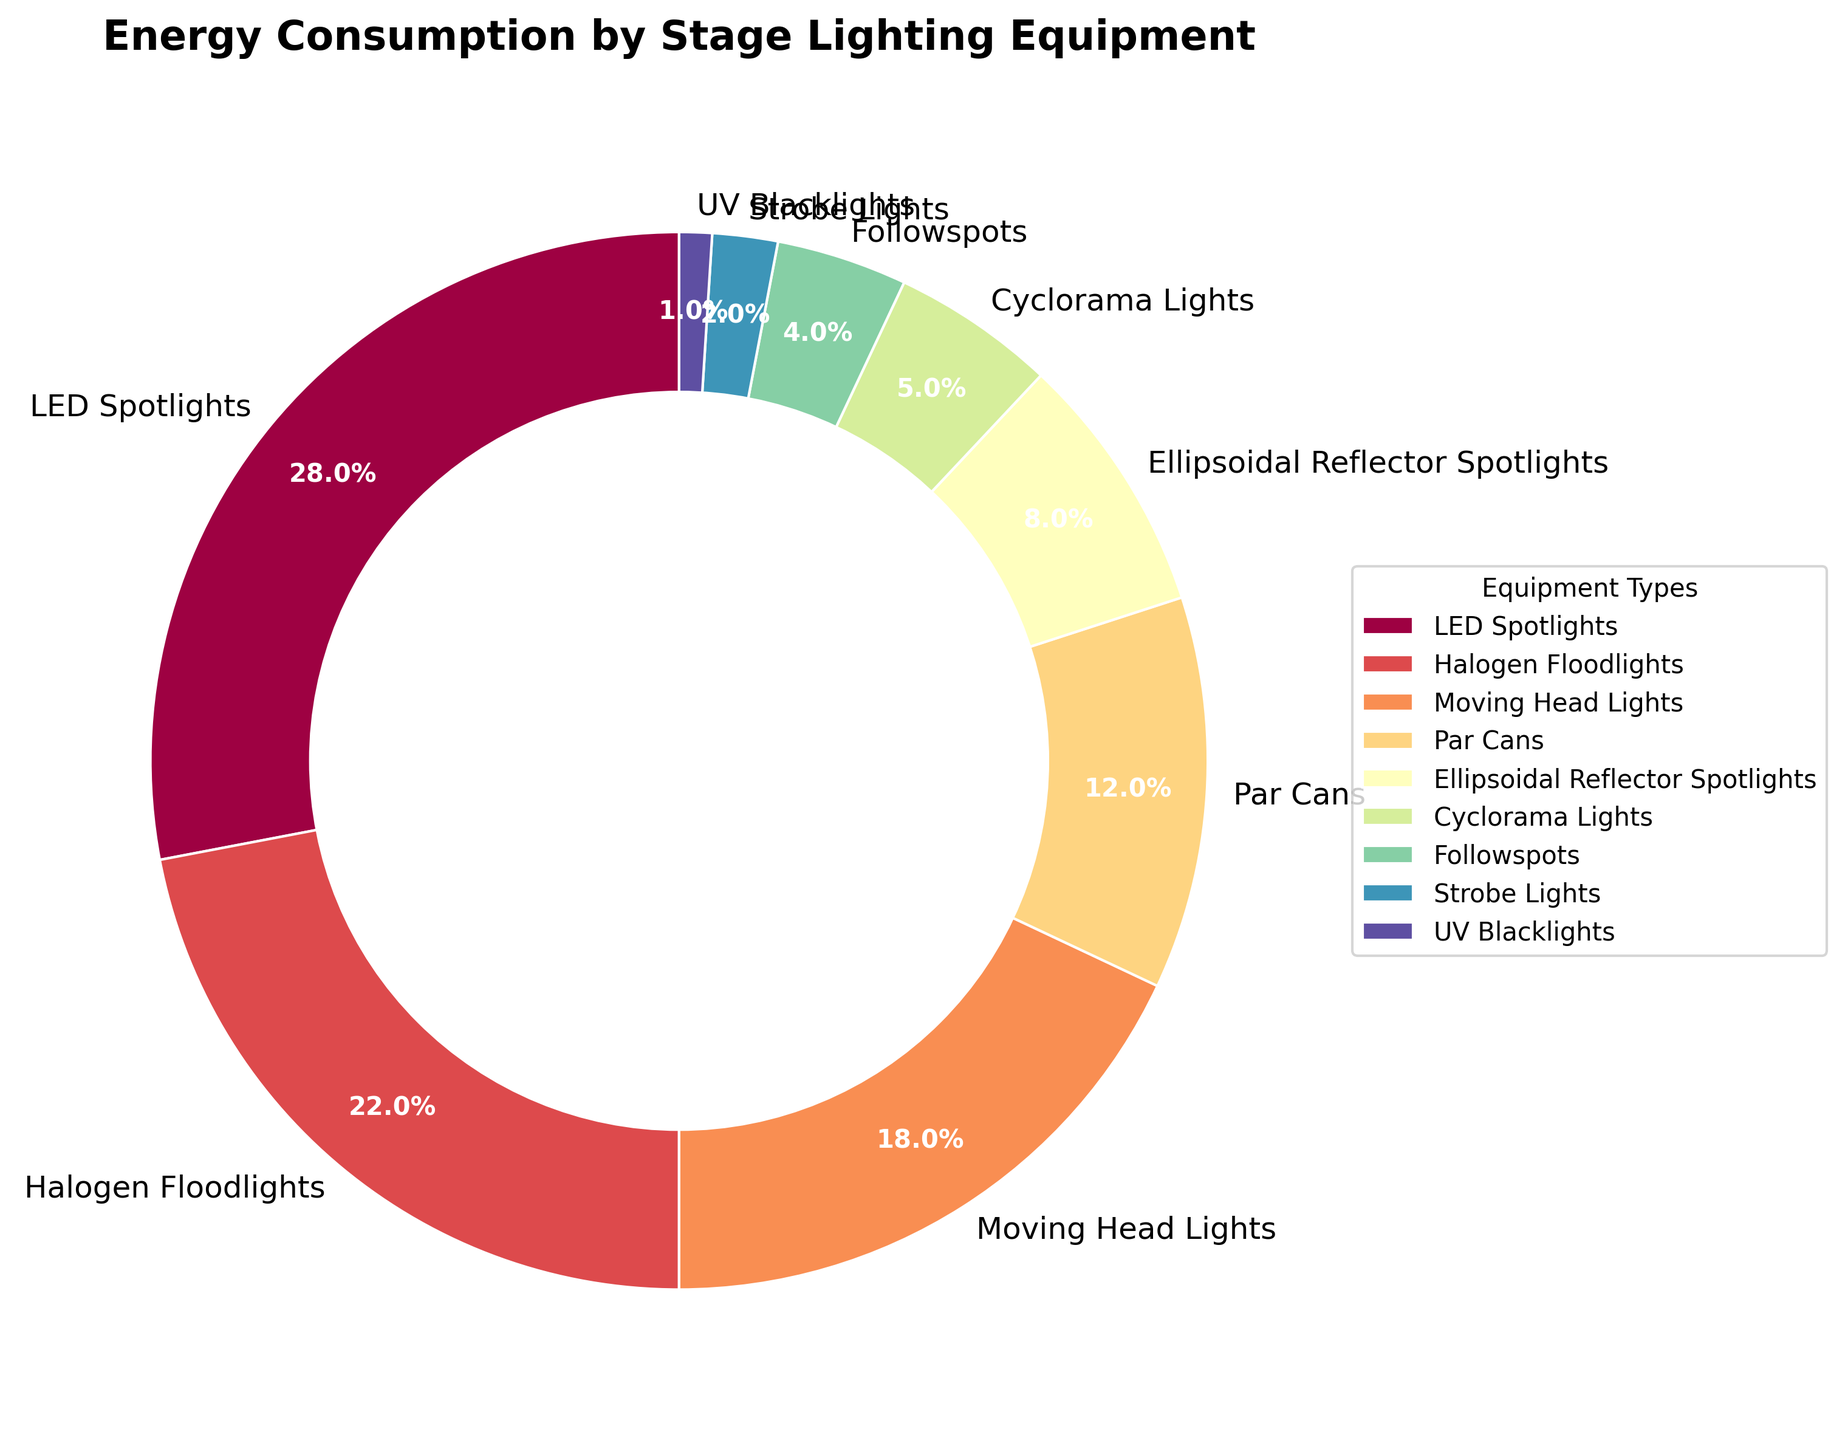What percentage of total energy consumption is used by LED Spotlights and Halogen Floodlights combined? First, identify the percentages for LED Spotlights (28%) and Halogen Floodlights (22%). Then, add these two values together: 28% + 22% = 50%.
Answer: 50% Which lighting equipment consumes more energy, Moving Head Lights or Ellipsoidal Reflector Spotlights? Moving Head Lights consume 18% of energy, whereas Ellipsoidal Reflector Spotlights consume 8%. Since 18% is greater than 8%, Moving Head Lights consume more energy.
Answer: Moving Head Lights What is the ratio of energy consumption between Par Cans and Cyclorama Lights? Par Cans consume 12% of energy whereas Cyclorama Lights consume 5%. The ratio is calculated as 12% / 5%, which simplifies to 2.4:1.
Answer: 2.4:1 Are there any lighting equipments that consume less than 5% of the total energy? If so, which ones? From the chart, Followspots consume 4%, Strobe Lights consume 2%, and UV Blacklights consume 1%. Each of these percentages is less than 5%.
Answer: Followspots, Strobe Lights, UV Blacklights What is the difference in energy consumption between Halogen Floodlights and Par Cans? Halogen Floodlights consume 22% of energy while Par Cans consume 12%. The difference is calculated as 22% - 12% = 10%.
Answer: 10% If you were to combine the energy consumption of Followspots, Strobe Lights, and UV Blacklights, would their total be greater or less than that of Cyclorama Lights? Followspots, Strobe Lights, and UV Blacklights consume 4%, 2%, and 1% respectively. Combined, they consume 4% + 2% + 1% = 7%. Cyclorama Lights consume 5%, so 7% is greater than 5%.
Answer: Greater Which equipment type has the lowest energy consumption? According to the pie chart, UV Blacklights have the lowest energy consumption at 1%.
Answer: UV Blacklights Among the equipment types listed, which has the highest energy consumption? The pie chart shows that LED Spotlights have the highest energy consumption at 28%.
Answer: LED Spotlights 